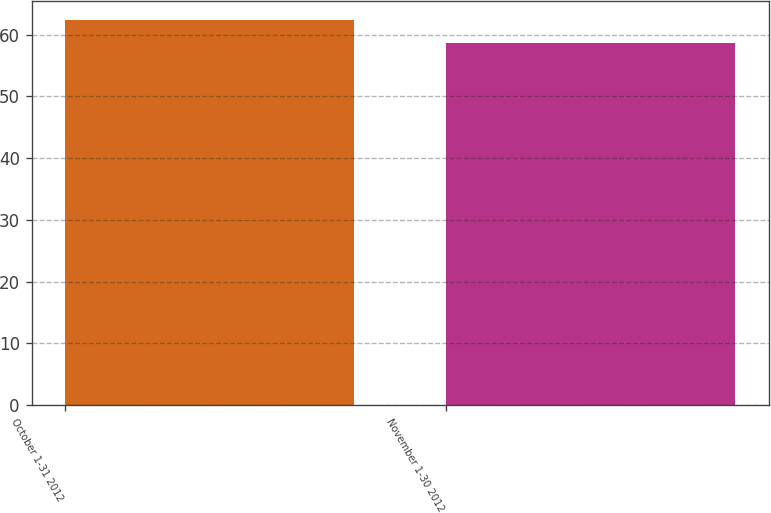Convert chart. <chart><loc_0><loc_0><loc_500><loc_500><bar_chart><fcel>October 1-31 2012<fcel>November 1-30 2012<nl><fcel>62.31<fcel>58.7<nl></chart> 